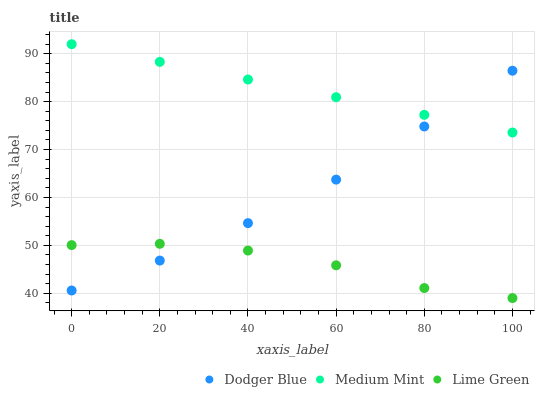Does Lime Green have the minimum area under the curve?
Answer yes or no. Yes. Does Medium Mint have the maximum area under the curve?
Answer yes or no. Yes. Does Dodger Blue have the minimum area under the curve?
Answer yes or no. No. Does Dodger Blue have the maximum area under the curve?
Answer yes or no. No. Is Medium Mint the smoothest?
Answer yes or no. Yes. Is Lime Green the roughest?
Answer yes or no. Yes. Is Dodger Blue the smoothest?
Answer yes or no. No. Is Dodger Blue the roughest?
Answer yes or no. No. Does Lime Green have the lowest value?
Answer yes or no. Yes. Does Dodger Blue have the lowest value?
Answer yes or no. No. Does Medium Mint have the highest value?
Answer yes or no. Yes. Does Dodger Blue have the highest value?
Answer yes or no. No. Is Lime Green less than Medium Mint?
Answer yes or no. Yes. Is Medium Mint greater than Lime Green?
Answer yes or no. Yes. Does Dodger Blue intersect Medium Mint?
Answer yes or no. Yes. Is Dodger Blue less than Medium Mint?
Answer yes or no. No. Is Dodger Blue greater than Medium Mint?
Answer yes or no. No. Does Lime Green intersect Medium Mint?
Answer yes or no. No. 